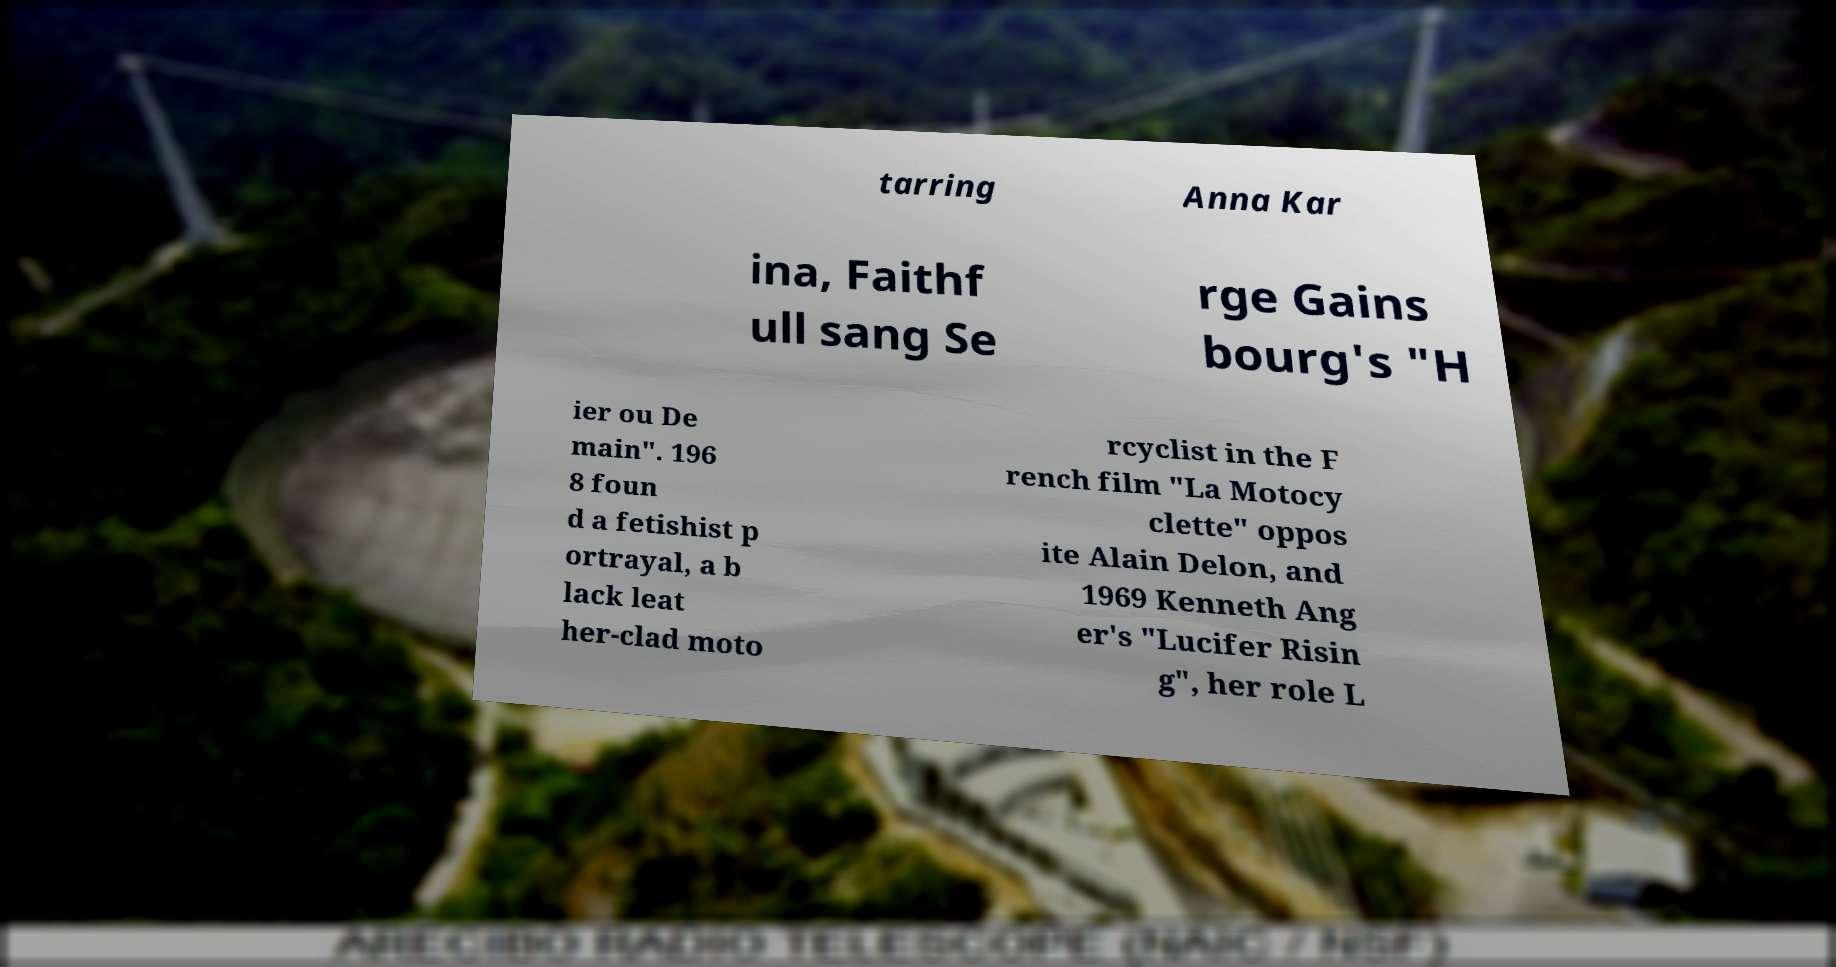Please identify and transcribe the text found in this image. tarring Anna Kar ina, Faithf ull sang Se rge Gains bourg's "H ier ou De main". 196 8 foun d a fetishist p ortrayal, a b lack leat her-clad moto rcyclist in the F rench film "La Motocy clette" oppos ite Alain Delon, and 1969 Kenneth Ang er's "Lucifer Risin g", her role L 